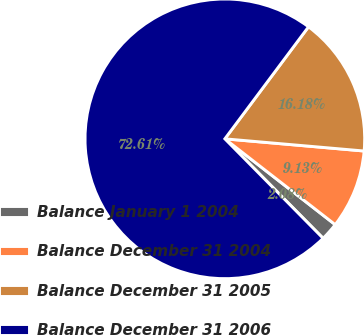<chart> <loc_0><loc_0><loc_500><loc_500><pie_chart><fcel>Balance January 1 2004<fcel>Balance December 31 2004<fcel>Balance December 31 2005<fcel>Balance December 31 2006<nl><fcel>2.08%<fcel>9.13%<fcel>16.18%<fcel>72.61%<nl></chart> 